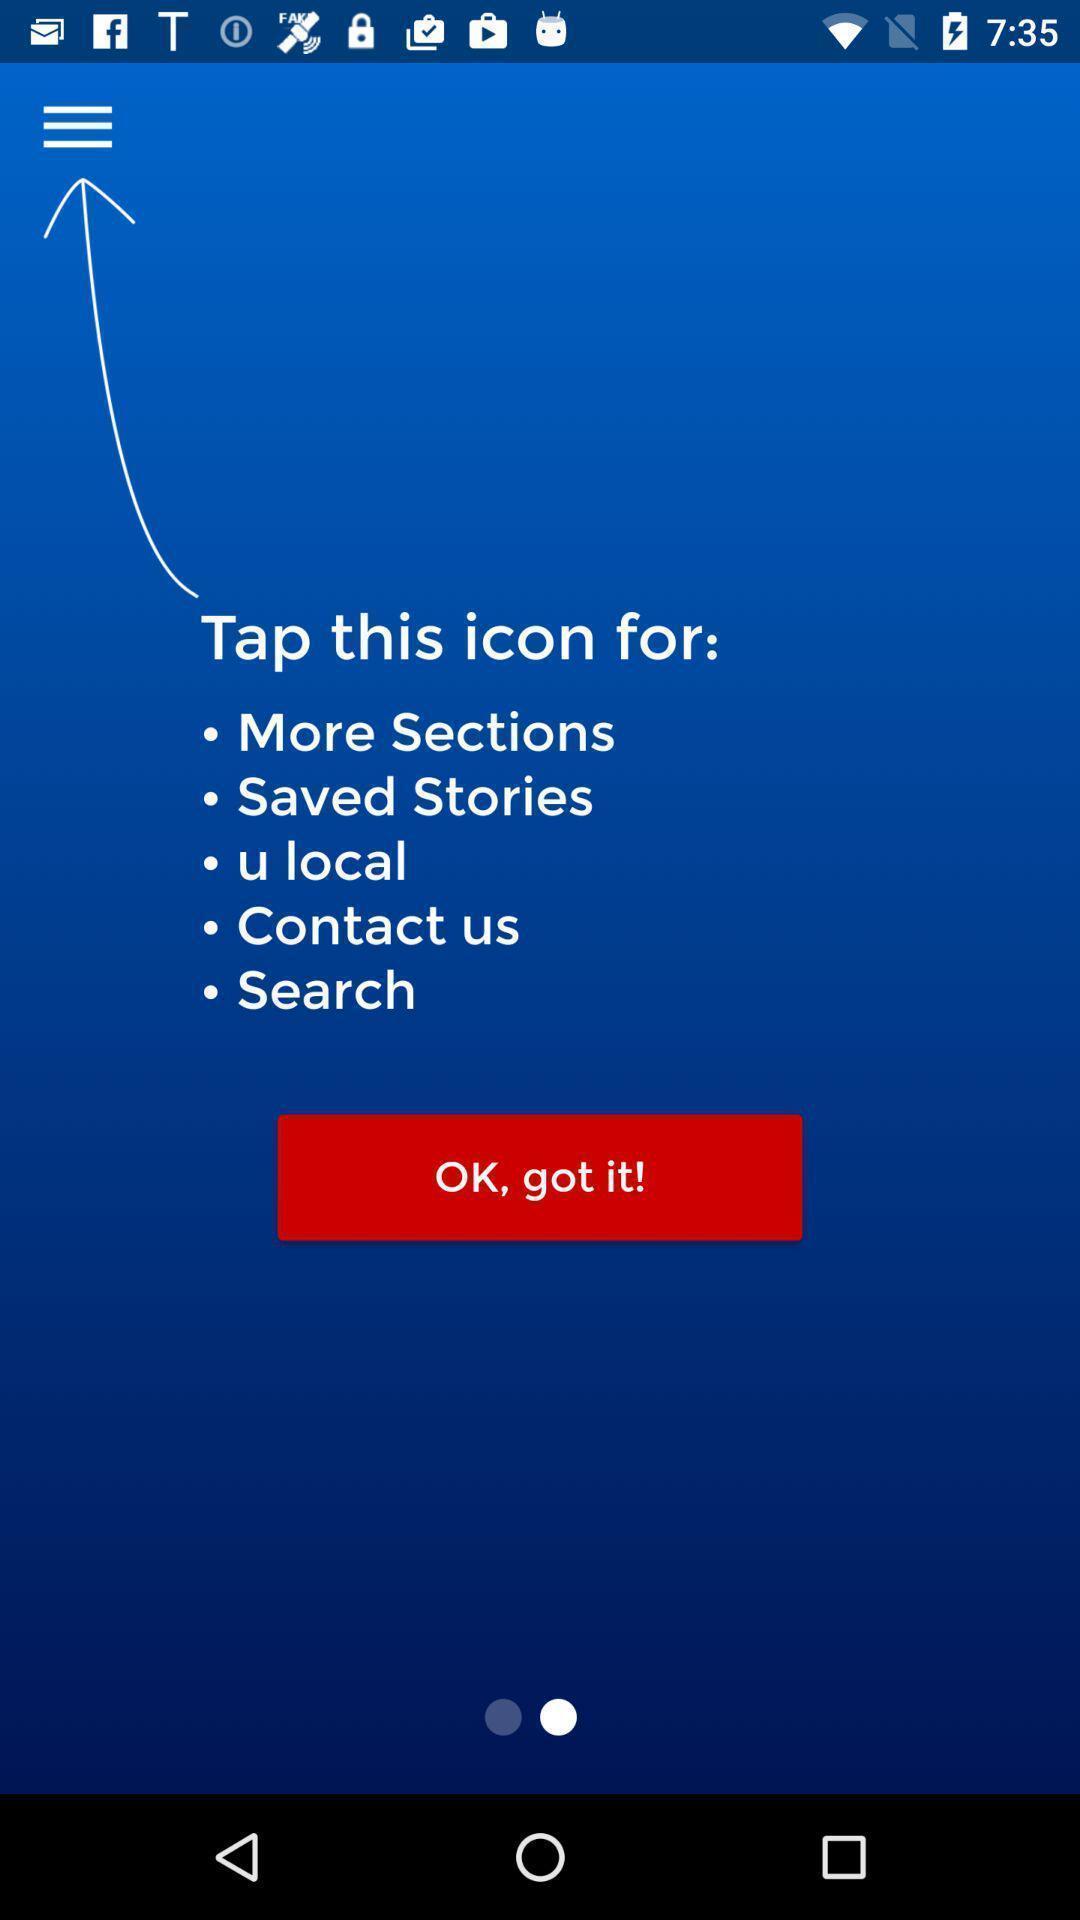Give me a narrative description of this picture. Welcome page. 